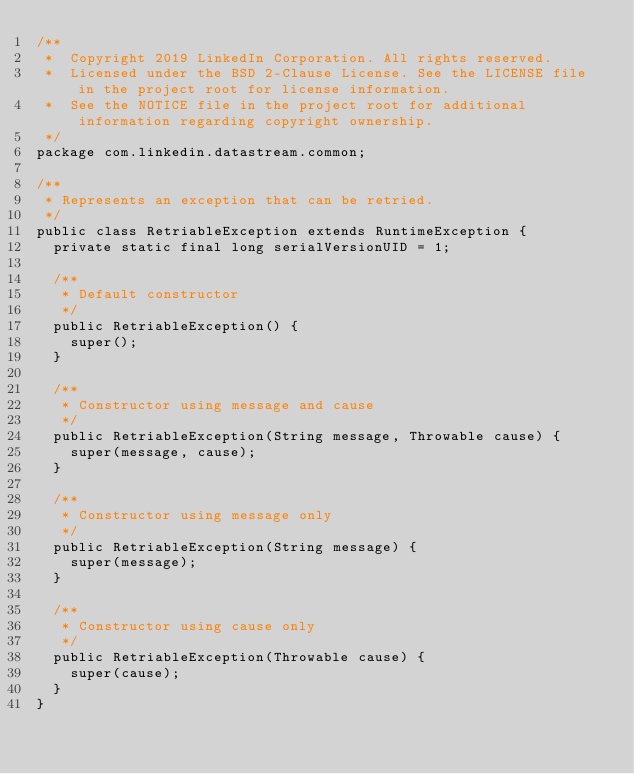Convert code to text. <code><loc_0><loc_0><loc_500><loc_500><_Java_>/**
 *  Copyright 2019 LinkedIn Corporation. All rights reserved.
 *  Licensed under the BSD 2-Clause License. See the LICENSE file in the project root for license information.
 *  See the NOTICE file in the project root for additional information regarding copyright ownership.
 */
package com.linkedin.datastream.common;

/**
 * Represents an exception that can be retried.
 */
public class RetriableException extends RuntimeException {
  private static final long serialVersionUID = 1;

  /**
   * Default constructor
   */
  public RetriableException() {
    super();
  }

  /**
   * Constructor using message and cause
   */
  public RetriableException(String message, Throwable cause) {
    super(message, cause);
  }

  /**
   * Constructor using message only
   */
  public RetriableException(String message) {
    super(message);
  }

  /**
   * Constructor using cause only
   */
  public RetriableException(Throwable cause) {
    super(cause);
  }
}
</code> 